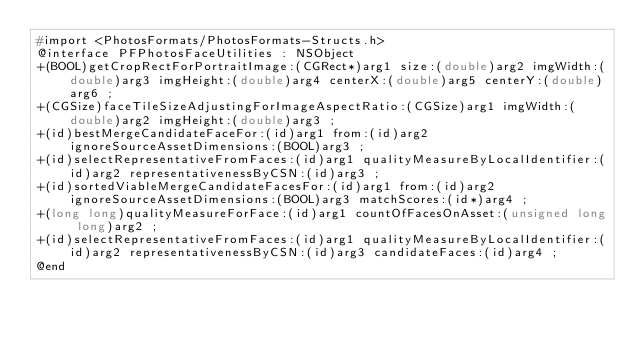<code> <loc_0><loc_0><loc_500><loc_500><_C_>#import <PhotosFormats/PhotosFormats-Structs.h>
@interface PFPhotosFaceUtilities : NSObject
+(BOOL)getCropRectForPortraitImage:(CGRect*)arg1 size:(double)arg2 imgWidth:(double)arg3 imgHeight:(double)arg4 centerX:(double)arg5 centerY:(double)arg6 ;
+(CGSize)faceTileSizeAdjustingForImageAspectRatio:(CGSize)arg1 imgWidth:(double)arg2 imgHeight:(double)arg3 ;
+(id)bestMergeCandidateFaceFor:(id)arg1 from:(id)arg2 ignoreSourceAssetDimensions:(BOOL)arg3 ;
+(id)selectRepresentativeFromFaces:(id)arg1 qualityMeasureByLocalIdentifier:(id)arg2 representativenessByCSN:(id)arg3 ;
+(id)sortedViableMergeCandidateFacesFor:(id)arg1 from:(id)arg2 ignoreSourceAssetDimensions:(BOOL)arg3 matchScores:(id*)arg4 ;
+(long long)qualityMeasureForFace:(id)arg1 countOfFacesOnAsset:(unsigned long long)arg2 ;
+(id)selectRepresentativeFromFaces:(id)arg1 qualityMeasureByLocalIdentifier:(id)arg2 representativenessByCSN:(id)arg3 candidateFaces:(id)arg4 ;
@end

</code> 